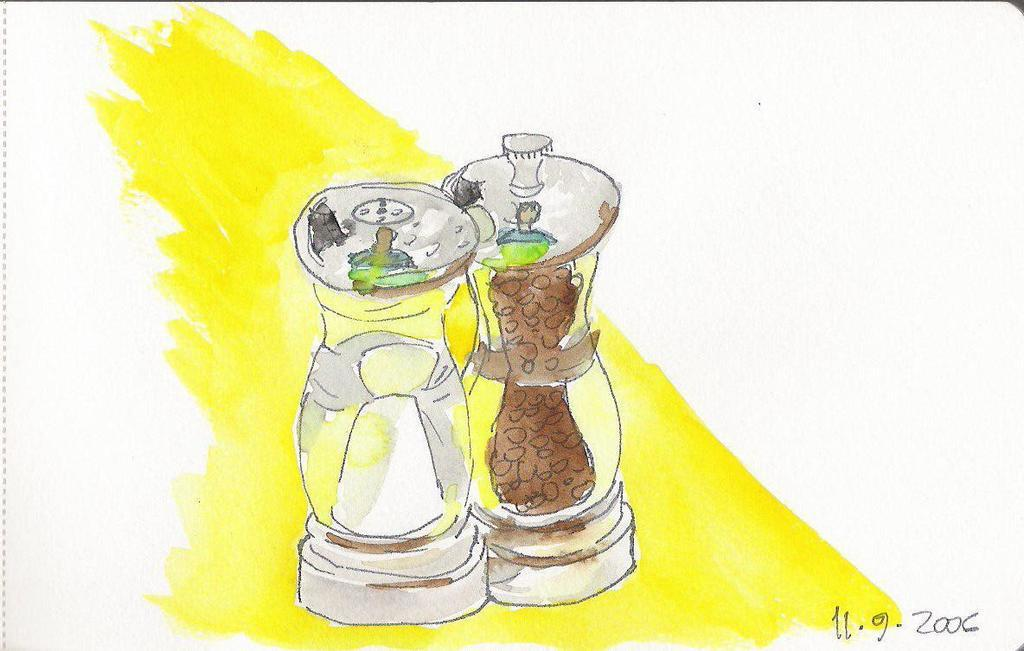<image>
Give a short and clear explanation of the subsequent image. Drawing of salt and pepper that was  done on November 9th 2006. 